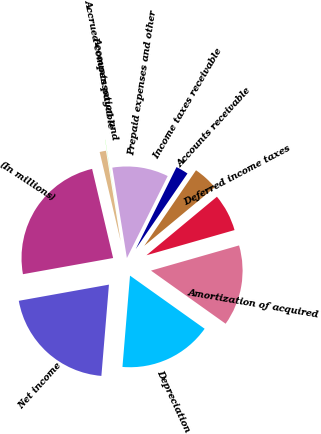Convert chart. <chart><loc_0><loc_0><loc_500><loc_500><pie_chart><fcel>(In millions)<fcel>Net income<fcel>Depreciation<fcel>Amortization of acquired<fcel>Deferred income taxes<fcel>Accounts receivable<fcel>Income taxes receivable<fcel>Prepaid expenses and other<fcel>Accounts payable<fcel>Accrued compensation and<nl><fcel>24.14%<fcel>20.86%<fcel>16.47%<fcel>14.28%<fcel>6.6%<fcel>4.41%<fcel>2.21%<fcel>9.89%<fcel>0.02%<fcel>1.12%<nl></chart> 